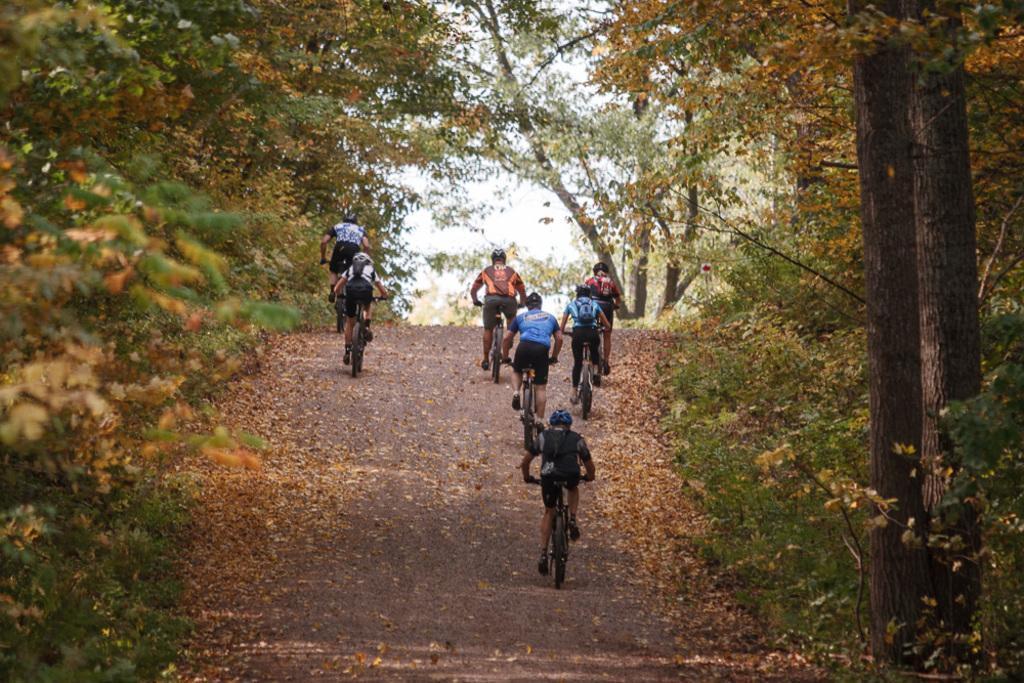Could you give a brief overview of what you see in this image? In this image I can see a group of people are riding bicycles on the road and trees. In the background I can see the sky. This image is taken may be during a day. 